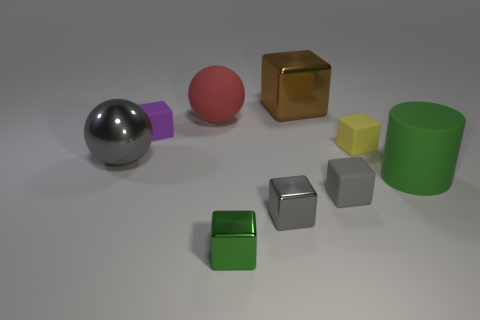What might the purpose of these objects be? Given the uniformity and the simple geometric forms, these objects might be intended for a visual demonstration, possibly related to geometry, physics, or an artistic composition. They could be used to teach about shapes, shading, and perspective, or even render tests in a 3D modeling software. 